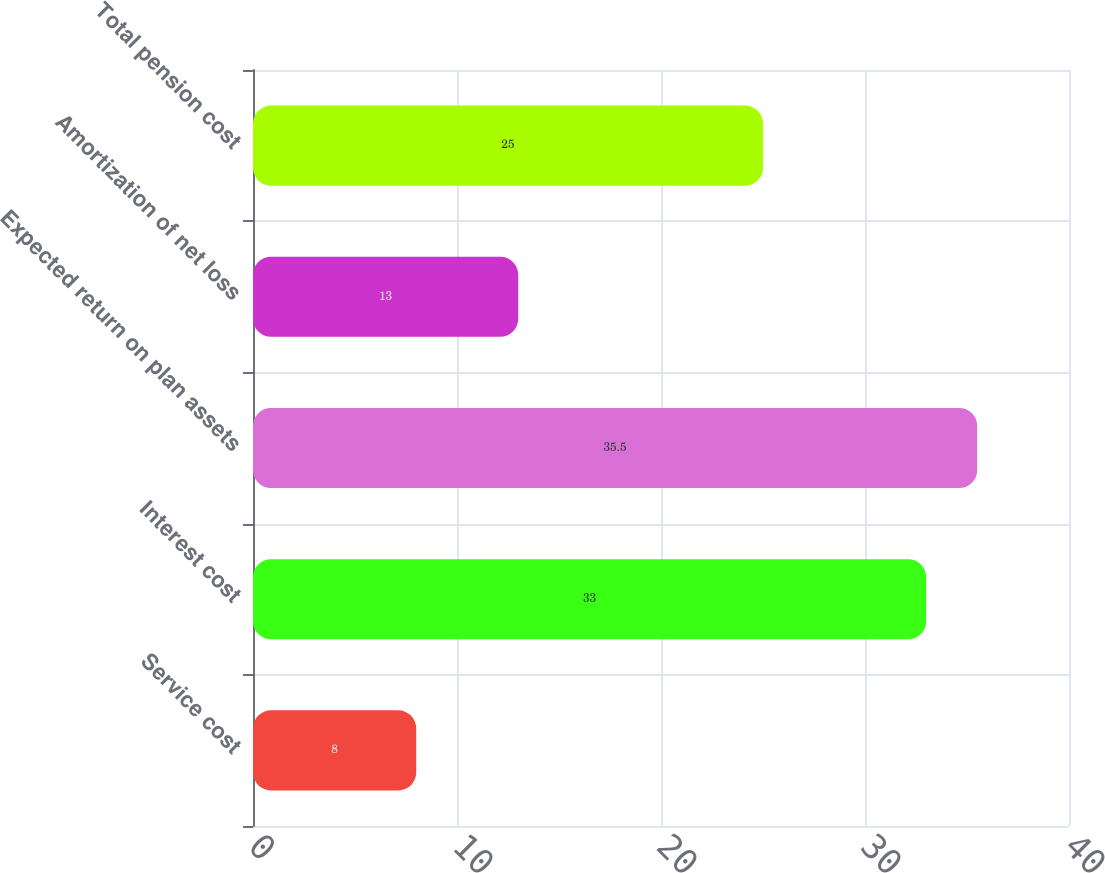<chart> <loc_0><loc_0><loc_500><loc_500><bar_chart><fcel>Service cost<fcel>Interest cost<fcel>Expected return on plan assets<fcel>Amortization of net loss<fcel>Total pension cost<nl><fcel>8<fcel>33<fcel>35.5<fcel>13<fcel>25<nl></chart> 